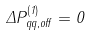Convert formula to latex. <formula><loc_0><loc_0><loc_500><loc_500>\Delta P ^ { ( 1 ) } _ { q q , o f f } = 0</formula> 